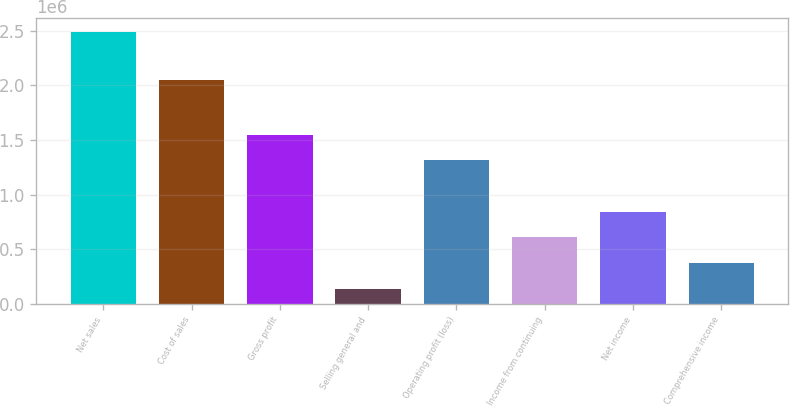Convert chart to OTSL. <chart><loc_0><loc_0><loc_500><loc_500><bar_chart><fcel>Net sales<fcel>Cost of sales<fcel>Gross profit<fcel>Selling general and<fcel>Operating profit (loss)<fcel>Income from continuing<fcel>Net income<fcel>Comprehensive income<nl><fcel>2.48997e+06<fcel>2.0501e+06<fcel>1.5483e+06<fcel>135805<fcel>1.31289e+06<fcel>606638<fcel>842054<fcel>371221<nl></chart> 